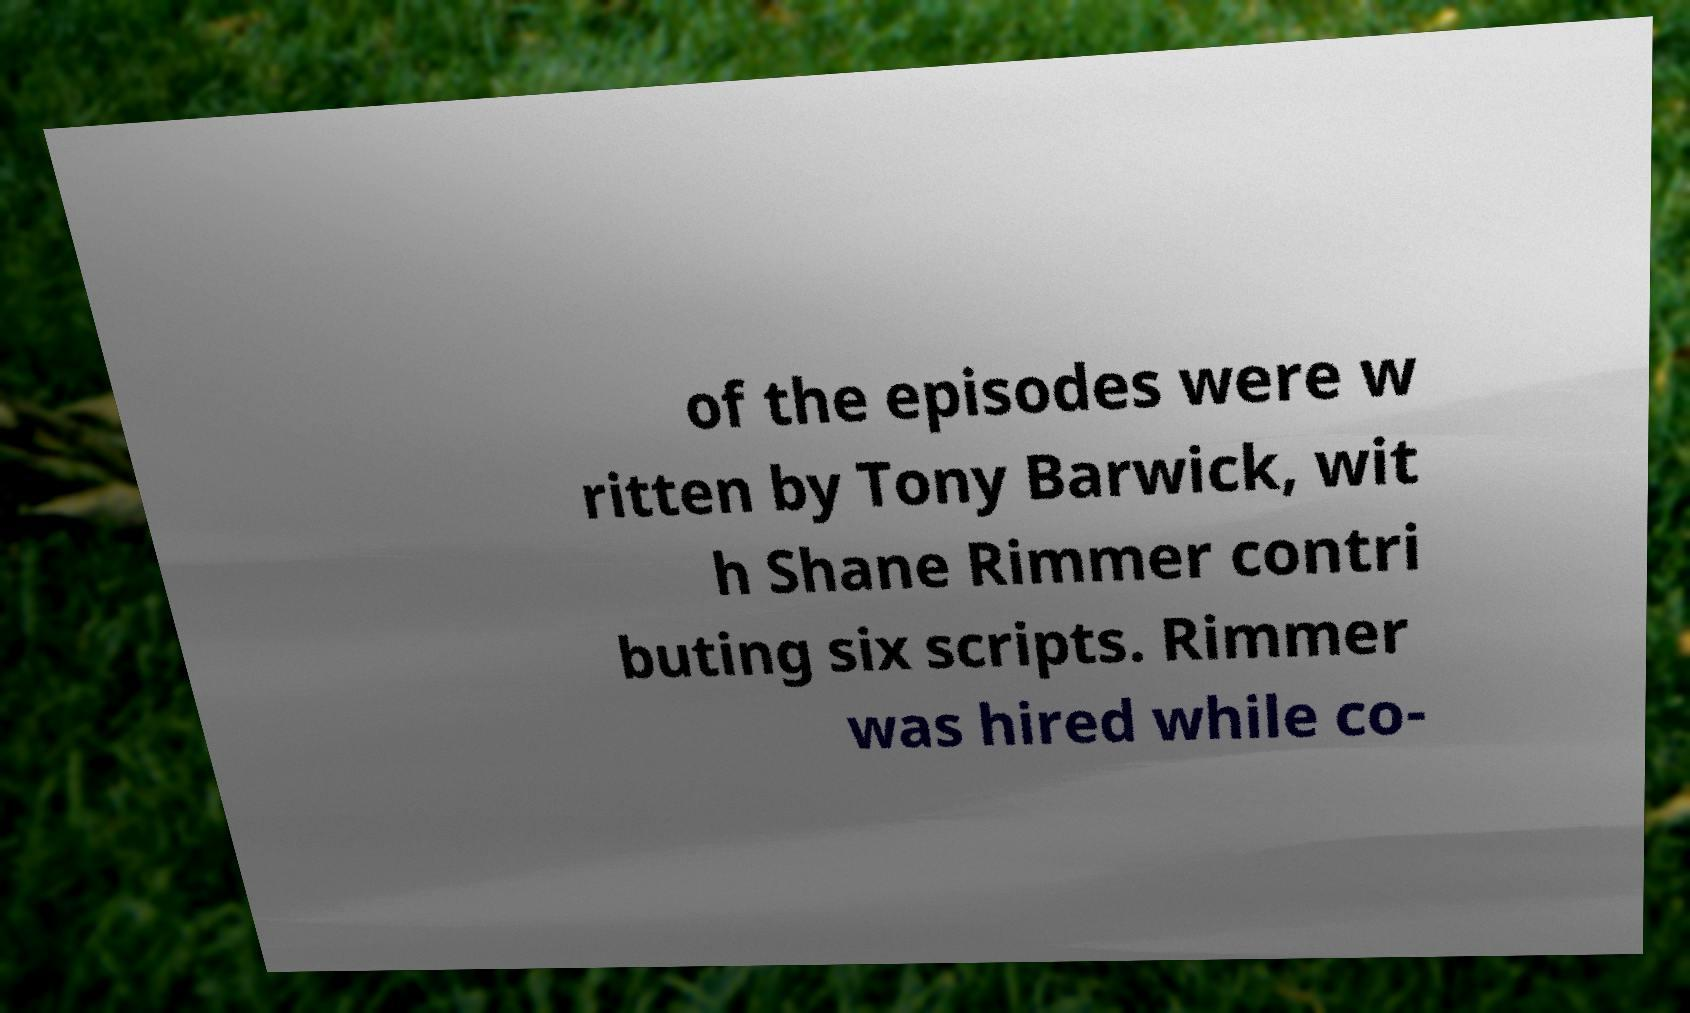Could you extract and type out the text from this image? of the episodes were w ritten by Tony Barwick, wit h Shane Rimmer contri buting six scripts. Rimmer was hired while co- 